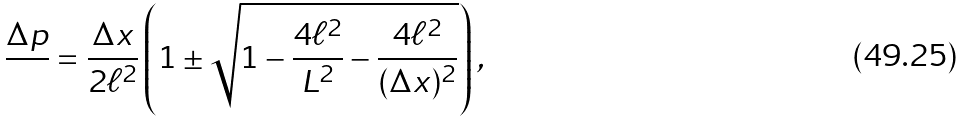<formula> <loc_0><loc_0><loc_500><loc_500>\frac { \Delta p } { } = \frac { \Delta x } { 2 \ell ^ { 2 } } \left ( 1 \pm \sqrt { 1 - \frac { 4 \ell ^ { 2 } } { L ^ { 2 } } - \frac { 4 \ell ^ { 2 } } { ( \Delta x ) ^ { 2 } } } \right ) ,</formula> 